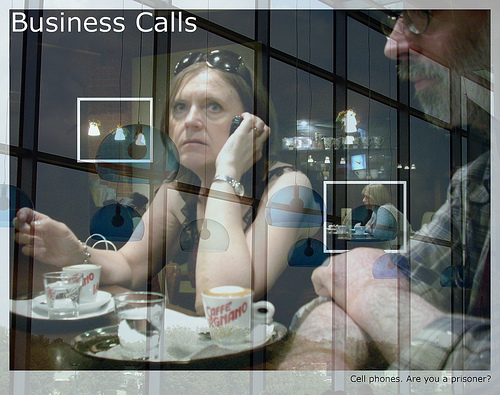What do you think is the primary subject of the image? The primary subject of the image appears to be the woman talking on the phone, as she is centrally located and her expression is quite focused and prominent. What role do you think technology plays in the scenario depicted? Technology seems to play a crucial role in facilitating communication and business operations in the depicted scenario. The phone conversation appears integral to the woman's task, suggesting the pervasive influence of digital connectivity in modern professional settings. Imagine the coffee cup could talk. What might it say about the scene? If the coffee cup could talk, it might say: 'I've seen countless business deals and intense conversations take place here. The woman seems deeply engrossed in her call, reflecting the high-stakes nature of her work. The man beside me seems pensive and observant, perhaps awaiting his turn to speak. It's fascinating how much weight these conversations carry in their professional lives.' What do you think the people in the image will do right after the scene? After the scene, the woman might conclude her phone call and discuss the call's details with the man, who seems to be waiting to provide his input. They might then proceed to outline their next steps or action items to address any issues discussed during the call. Given the reflections, how does the image draw attention to the complexity of modern communication? The reflections in the image symbolize the multifaceted nature of modern communication, emphasizing its complexities. They create a layered effect, representing how conversations and decisions often involve multiple perspectives and unseen elements. The reflections blur the lines between different spaces and interactions, hinting at the interconnectedness of business and personal experiences in a digital age. Create a dialogue between the reflections and the human subjects in the image. Reflection: 'We silently witness every discussion, every decision, capturing moments that others might overlook. Your intense focus on the call and the contemplative posture of your colleague define this space.' 
Woman: 'This call is critical. Every detail has to be perfect. I can feel the importance of this moment reflected back at me.' 
Man: 'These meetings define our progress, our success. The reflections remind us of the weight our actions carry, seen and unseen.' 